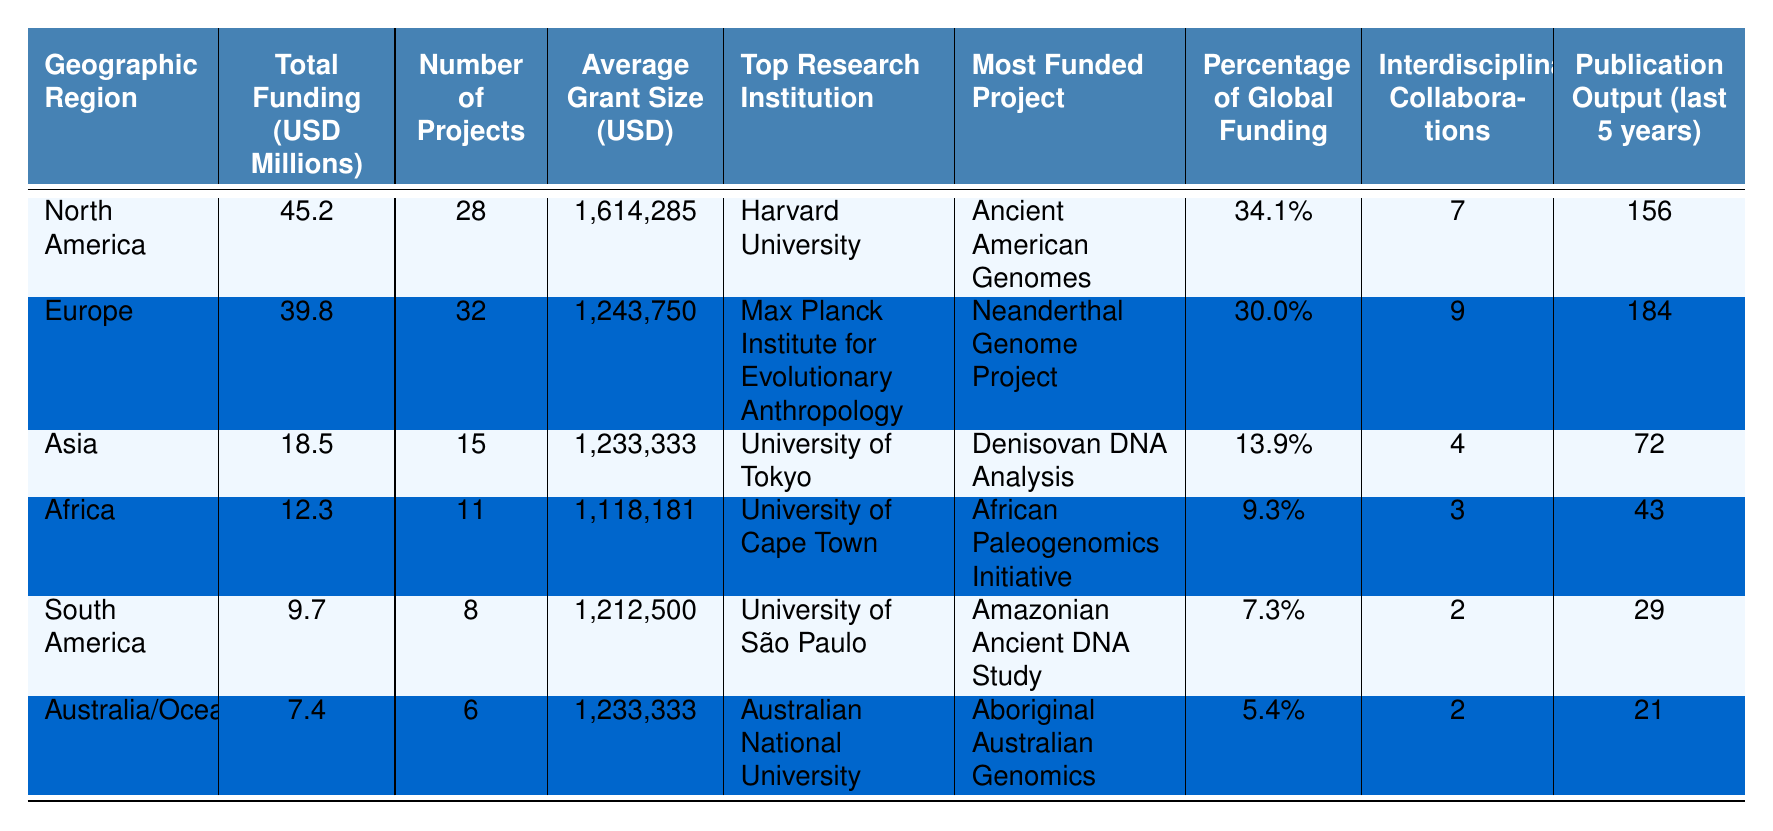What geographic region has the highest total funding for ancient DNA research? The table shows that North America has the highest total funding at 45.2 million USD.
Answer: North America What is the average grant size for projects in Europe? According to the table, the average grant size for projects in Europe is 1,243,750 USD.
Answer: 1,243,750 USD How many projects are funded in Asia? The table indicates that there are 15 projects funded in Asia.
Answer: 15 Which geographic region has the lowest percentage of global funding? By examining the table, it’s clear that Australia/Oceania has the lowest percentage of global funding at 5.4%.
Answer: Australia/Oceania What is the total funding for Africa and South America combined? Adding the total funding for Africa (12.3 million USD) and South America (9.7 million USD) gives a combined total of 22 million USD.
Answer: 22 million USD Which region has the most publication output in the last 5 years? The table shows that Europe has the highest publication output with 184 publications over the last five years.
Answer: Europe Is the average grant size for projects in North America greater than the average grant size in Africa? Yes, the average grant size in North America is 1,614,285 USD, while in Africa it is 1,118,181 USD, making North America's average grant size greater.
Answer: Yes How many interdisciplinary collaborations were reported for South America? The table states that South America has 2 interdisciplinary collaborations.
Answer: 2 What is the difference in total funding between North America and Europe? The total funding for North America is 45.2 million USD and for Europe is 39.8 million USD; thus, the difference is 5.4 million USD.
Answer: 5.4 million USD How does the number of projects in North America compare to the number of projects in Australia/Oceania? North America has 28 projects whereas Australia/Oceania has 6 projects, making North America have 22 more projects than Australia/Oceania.
Answer: 22 more projects Which project received the most funding in Asia? The table notes that the "Denisovan DNA Analysis" is the most funded project in Asia.
Answer: Denisovan DNA Analysis 